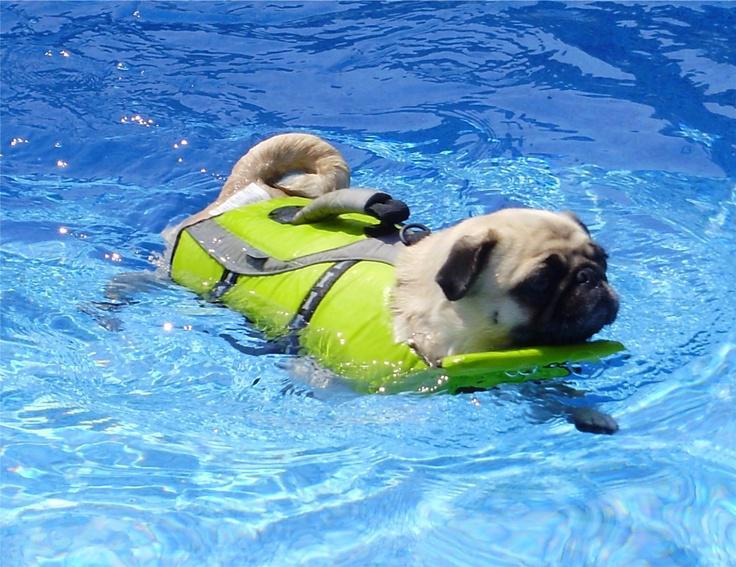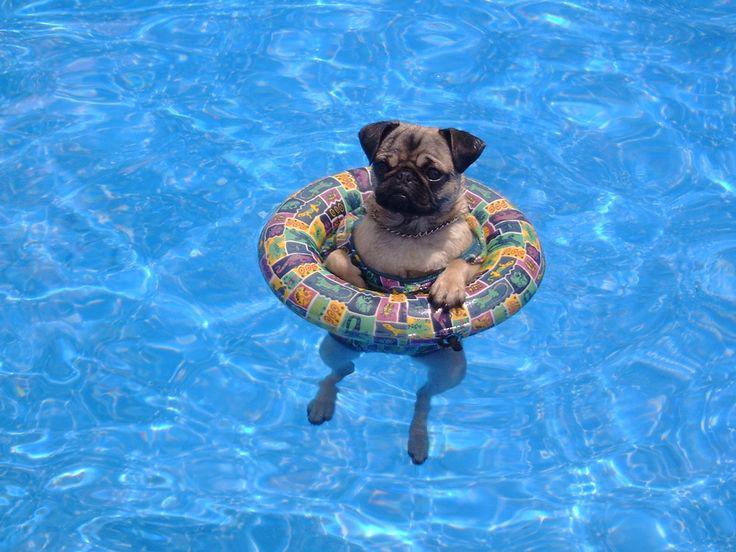The first image is the image on the left, the second image is the image on the right. Given the left and right images, does the statement "Two small dogs with pudgy noses and downturned ears are in a swimming pool aided by a floatation device." hold true? Answer yes or no. Yes. The first image is the image on the left, the second image is the image on the right. For the images shown, is this caption "An image shows a rightward facing dog in a pool with no flotation device." true? Answer yes or no. No. 